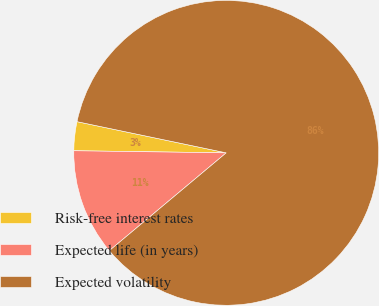Convert chart to OTSL. <chart><loc_0><loc_0><loc_500><loc_500><pie_chart><fcel>Risk-free interest rates<fcel>Expected life (in years)<fcel>Expected volatility<nl><fcel>3.06%<fcel>11.31%<fcel>85.63%<nl></chart> 